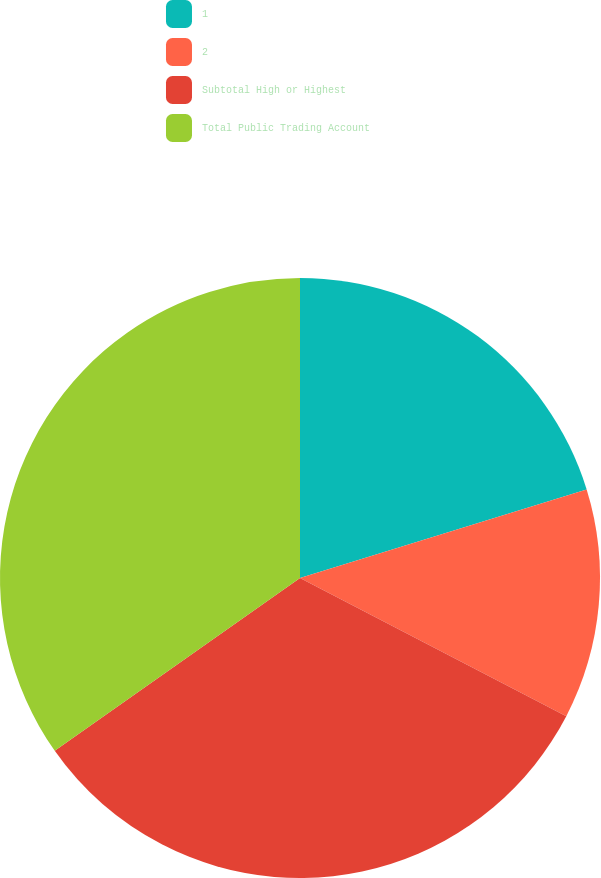<chart> <loc_0><loc_0><loc_500><loc_500><pie_chart><fcel>1<fcel>2<fcel>Subtotal High or Highest<fcel>Total Public Trading Account<nl><fcel>20.24%<fcel>12.38%<fcel>32.62%<fcel>34.77%<nl></chart> 